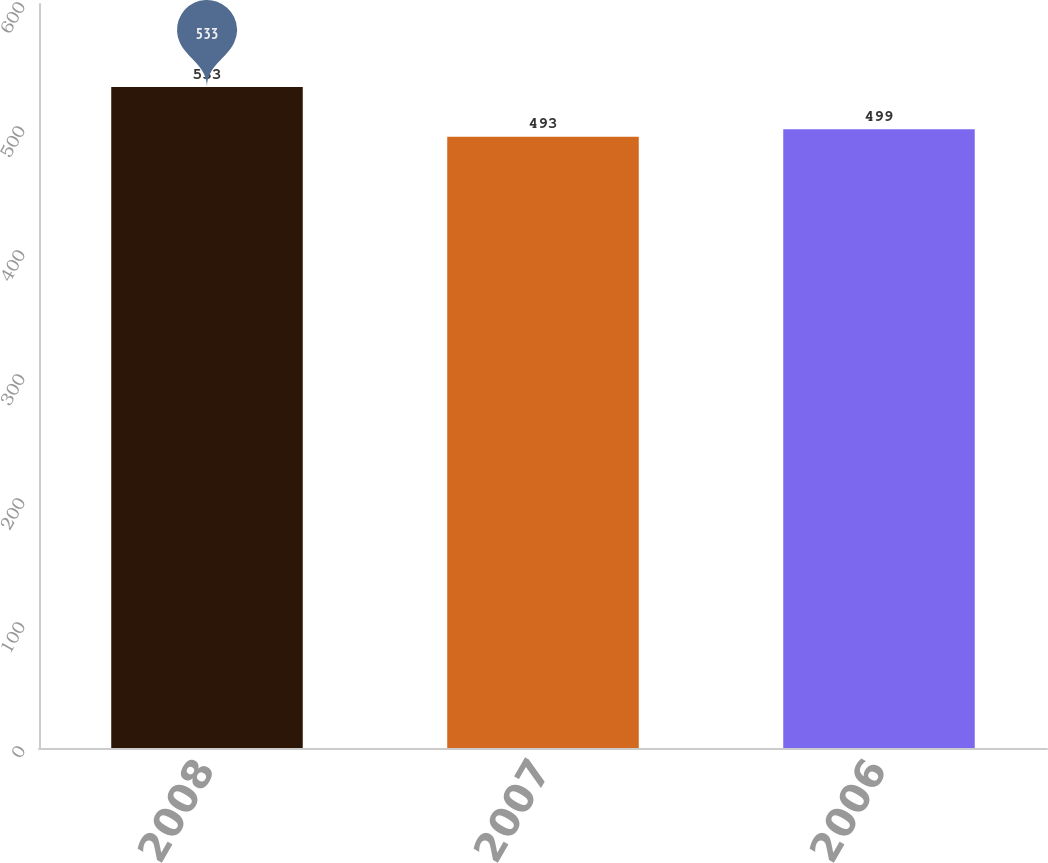<chart> <loc_0><loc_0><loc_500><loc_500><bar_chart><fcel>2008<fcel>2007<fcel>2006<nl><fcel>533<fcel>493<fcel>499<nl></chart> 